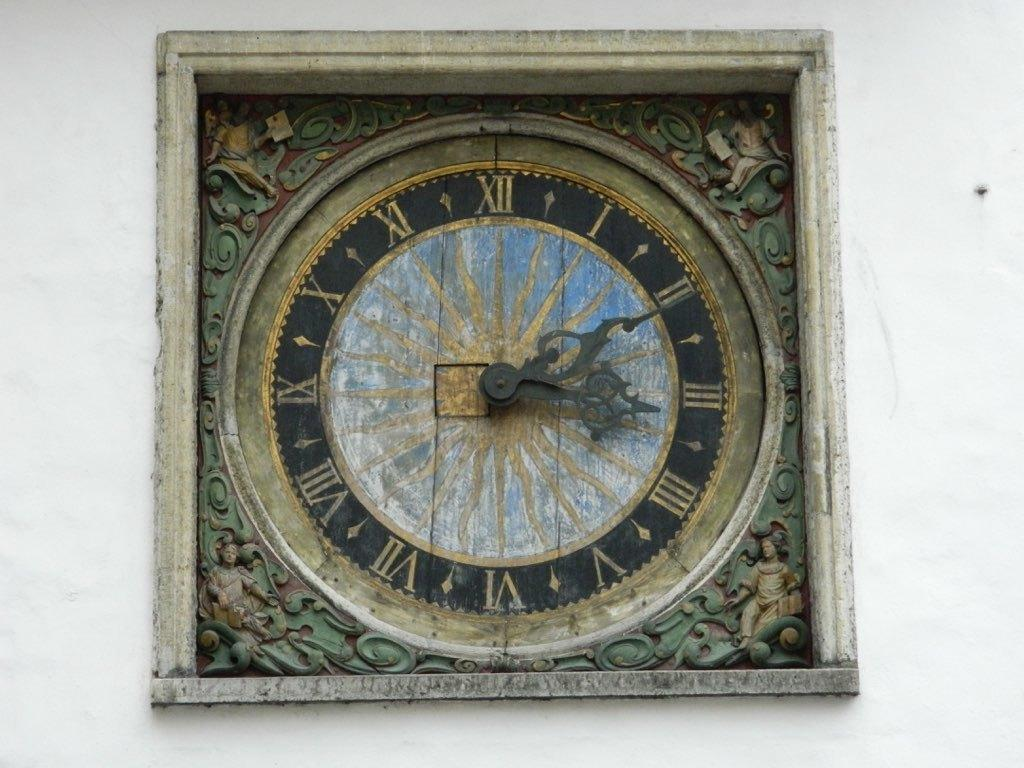<image>
Offer a succinct explanation of the picture presented. A very old clock says that it is 11 minutes past three o'clock. 